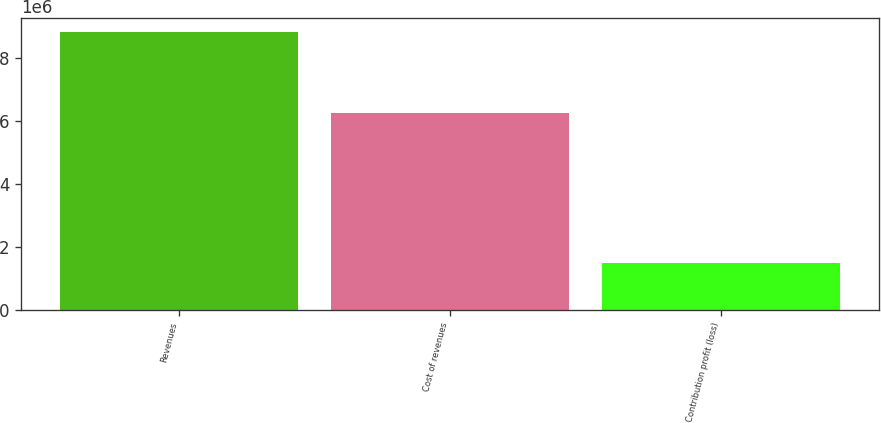Convert chart to OTSL. <chart><loc_0><loc_0><loc_500><loc_500><bar_chart><fcel>Revenues<fcel>Cost of revenues<fcel>Contribution profit (loss)<nl><fcel>8.83067e+06<fcel>6.25746e+06<fcel>1.47569e+06<nl></chart> 